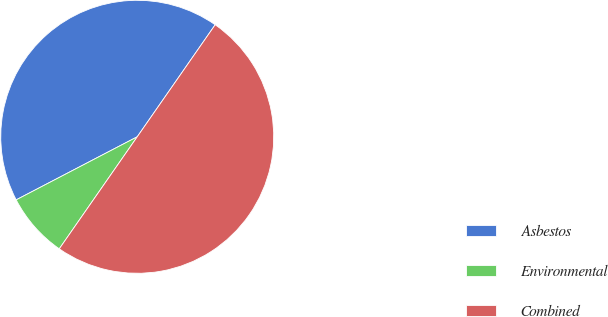<chart> <loc_0><loc_0><loc_500><loc_500><pie_chart><fcel>Asbestos<fcel>Environmental<fcel>Combined<nl><fcel>42.32%<fcel>7.68%<fcel>50.0%<nl></chart> 